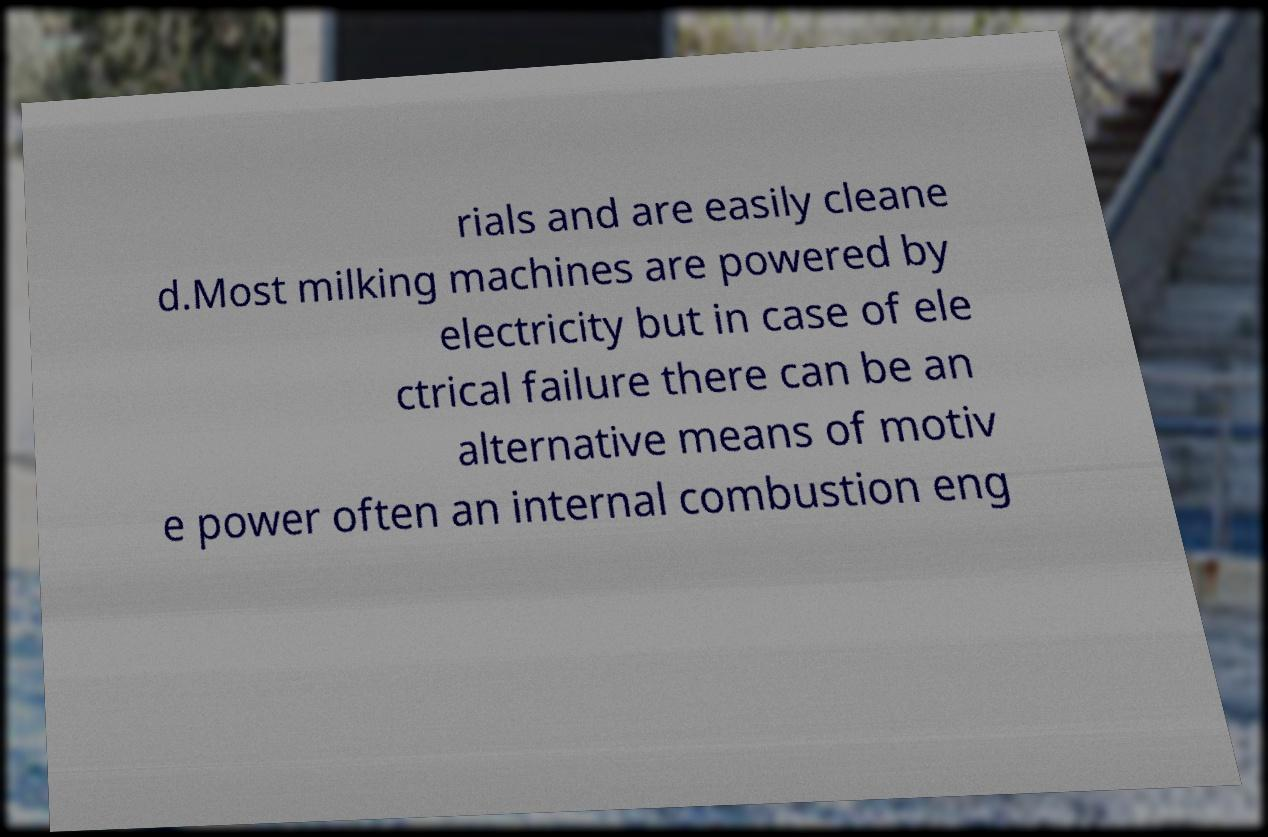Could you assist in decoding the text presented in this image and type it out clearly? rials and are easily cleane d.Most milking machines are powered by electricity but in case of ele ctrical failure there can be an alternative means of motiv e power often an internal combustion eng 